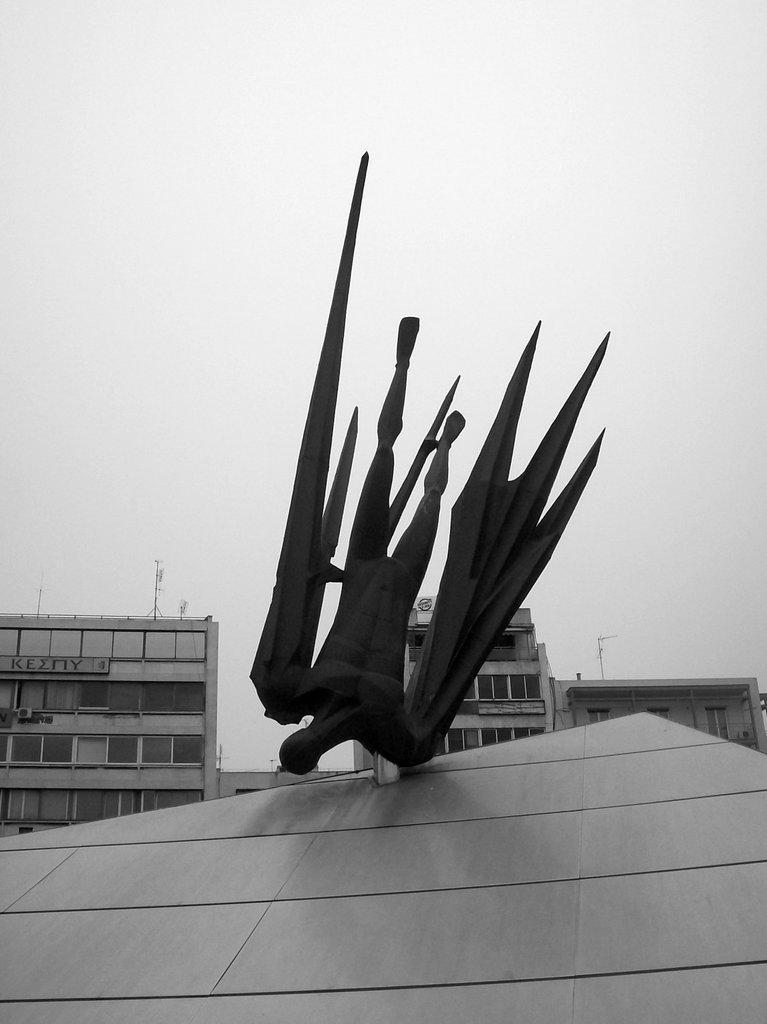Can you describe this image briefly? This is a black and white image. I can see the buildings and a sculpture on a surface. In the background, there is the sky. 